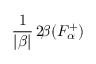<formula> <loc_0><loc_0><loc_500><loc_500>\frac { 1 } { | \beta | } \, 2 \, \beta ( F _ { \alpha } ^ { + } )</formula> 